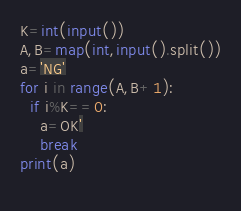Convert code to text. <code><loc_0><loc_0><loc_500><loc_500><_Python_>K=int(input())
A,B=map(int,input().split())
a='NG'
for i in range(A,B+1):
  if i%K==0:
    a=OK'
    break
print(a)
  
</code> 